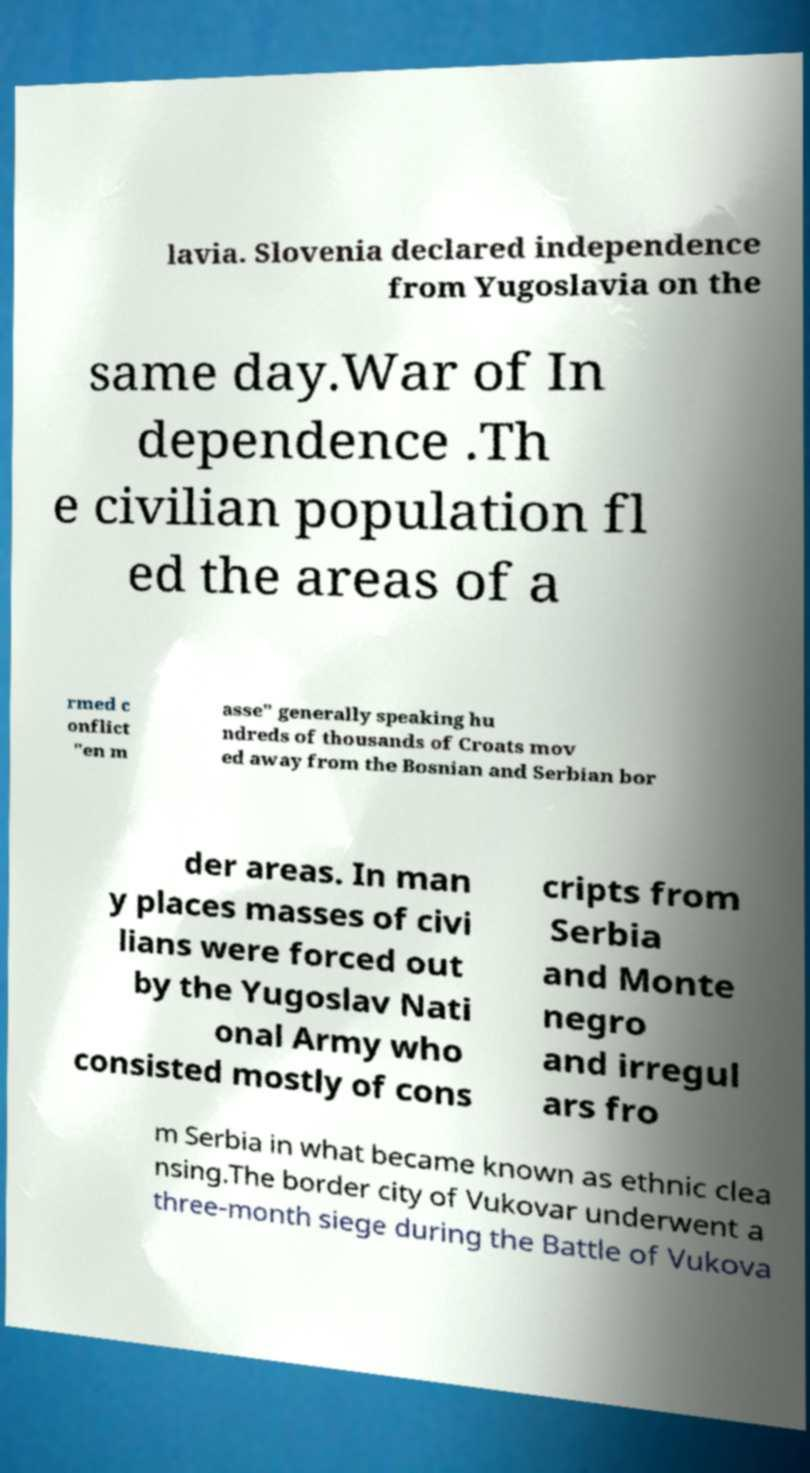Can you accurately transcribe the text from the provided image for me? lavia. Slovenia declared independence from Yugoslavia on the same day.War of In dependence .Th e civilian population fl ed the areas of a rmed c onflict "en m asse" generally speaking hu ndreds of thousands of Croats mov ed away from the Bosnian and Serbian bor der areas. In man y places masses of civi lians were forced out by the Yugoslav Nati onal Army who consisted mostly of cons cripts from Serbia and Monte negro and irregul ars fro m Serbia in what became known as ethnic clea nsing.The border city of Vukovar underwent a three-month siege during the Battle of Vukova 